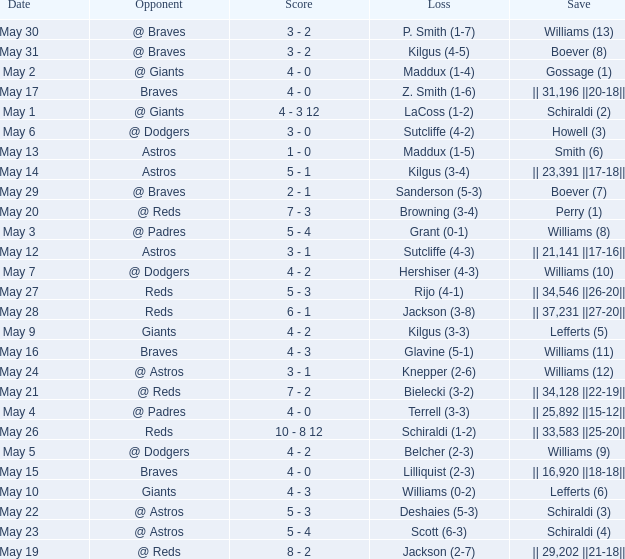Name the opponent for save of williams (9) @ Dodgers. 